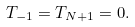<formula> <loc_0><loc_0><loc_500><loc_500>T _ { - 1 } = T _ { N + 1 } = 0 .</formula> 